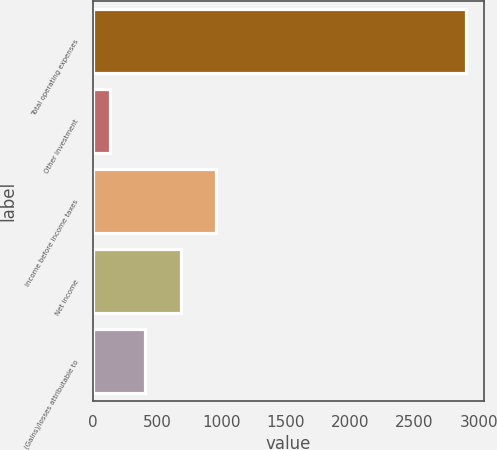Convert chart to OTSL. <chart><loc_0><loc_0><loc_500><loc_500><bar_chart><fcel>Total operating expenses<fcel>Other investment<fcel>Income before income taxes<fcel>Net income<fcel>(Gains)/losses attributable to<nl><fcel>2897.8<fcel>129.6<fcel>960.06<fcel>683.24<fcel>406.42<nl></chart> 